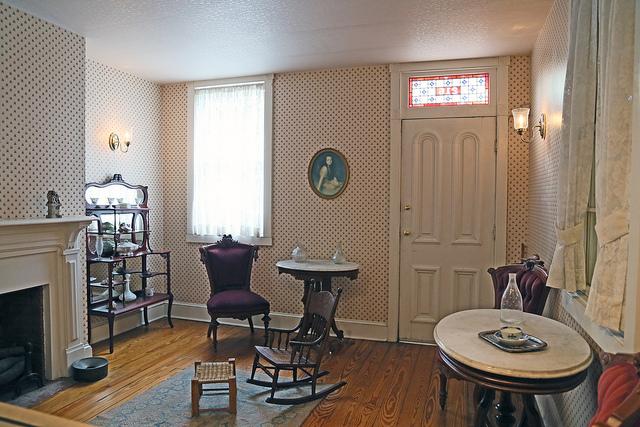How many windows are in the picture?
Be succinct. 2. Is the front door closed?
Quick response, please. Yes. Is there a fireplace?
Keep it brief. Yes. 